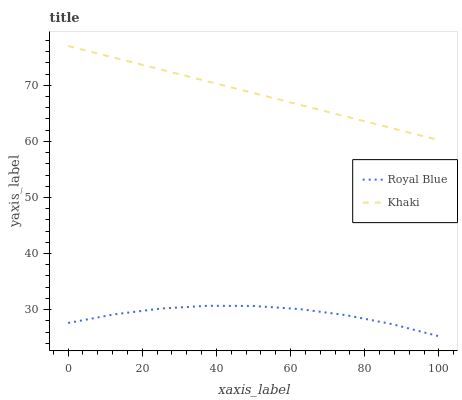Does Khaki have the minimum area under the curve?
Answer yes or no. No. Is Khaki the roughest?
Answer yes or no. No. Does Khaki have the lowest value?
Answer yes or no. No. Is Royal Blue less than Khaki?
Answer yes or no. Yes. Is Khaki greater than Royal Blue?
Answer yes or no. Yes. Does Royal Blue intersect Khaki?
Answer yes or no. No. 